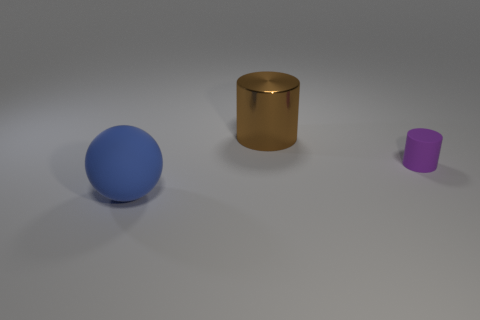How many tiny purple rubber objects are there?
Ensure brevity in your answer.  1. There is a object that is to the right of the shiny object; is its size the same as the brown metallic object?
Ensure brevity in your answer.  No. What number of metal objects are either tiny brown cylinders or big blue balls?
Make the answer very short. 0. What number of blue objects are behind the big thing that is behind the sphere?
Make the answer very short. 0. There is a thing that is both in front of the large brown thing and left of the rubber cylinder; what is its shape?
Keep it short and to the point. Sphere. There is a thing behind the rubber thing right of the blue thing to the left of the purple matte thing; what is it made of?
Offer a terse response. Metal. What is the small object made of?
Provide a succinct answer. Rubber. Is the material of the brown cylinder the same as the large object that is on the left side of the large brown shiny object?
Make the answer very short. No. The thing that is in front of the thing that is right of the large shiny cylinder is what color?
Your answer should be compact. Blue. How big is the object that is in front of the large brown cylinder and behind the blue thing?
Offer a very short reply. Small. 